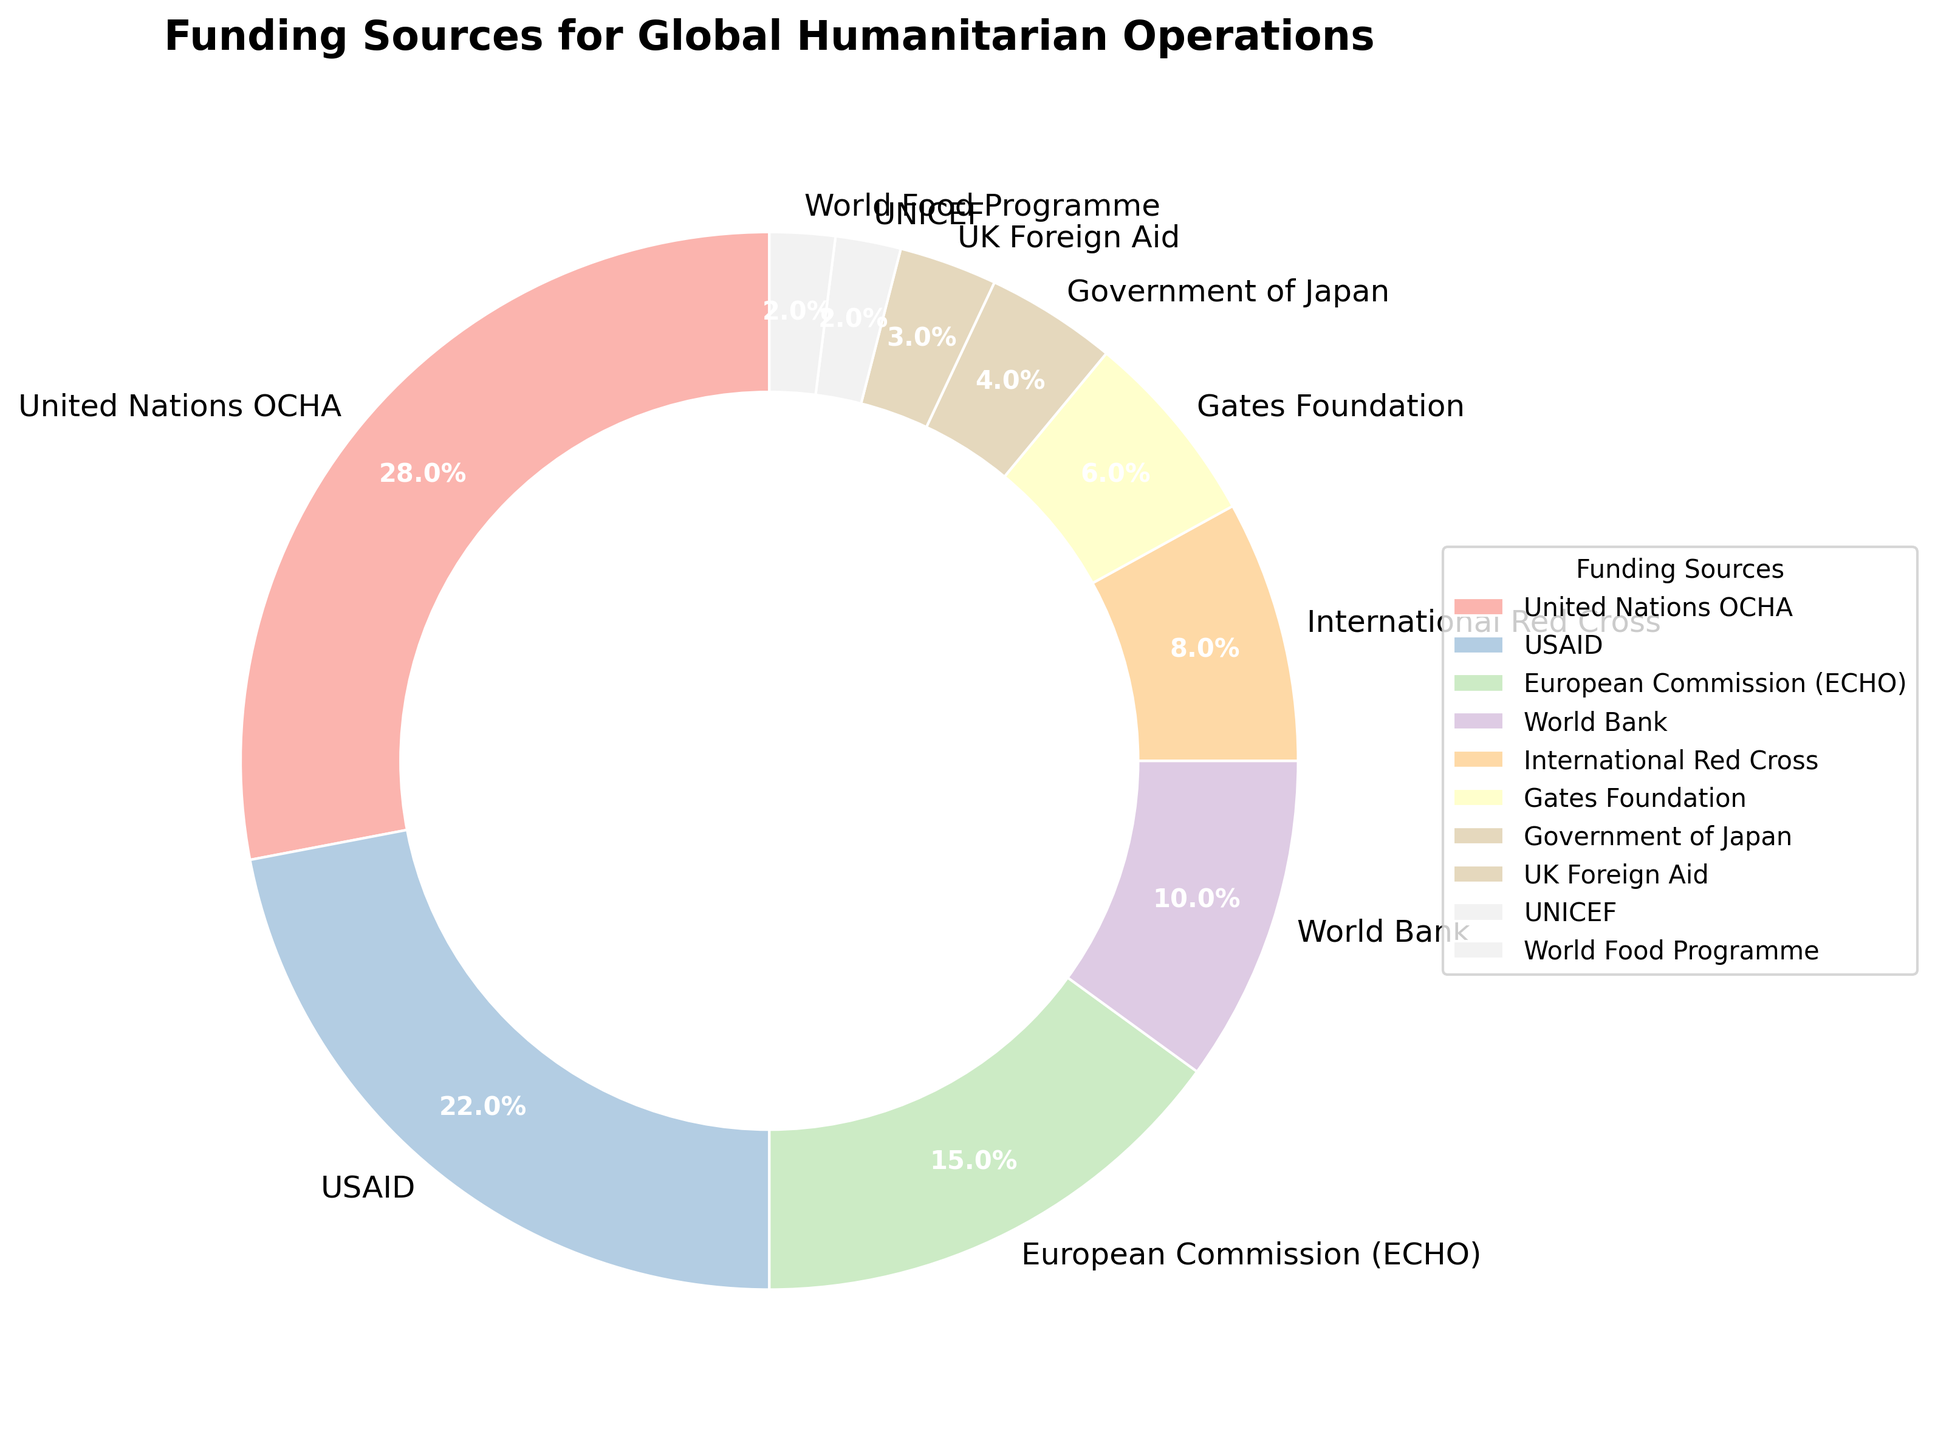Which funding source contributes the largest percentage? From the pie chart, the largest segment represents the United Nations OCHA with 28%, which is the highest among all funding sources.
Answer: United Nations OCHA What is the combined percentage of funding from USAID and the European Commission (ECHO)? The pie chart shows that USAID has 22% and the European Commission (ECHO) has 15%. Summing these percentages gives 22% + 15% = 37%.
Answer: 37% How does the percentage of funding from the World Bank compare to that from the International Red Cross? According to the pie chart, the World Bank contributes 10%, while the International Red Cross contributes 8%. Therefore, the World Bank contributes 2% more than the International Red Cross.
Answer: 2% more Which funding sources contribute less than 5% each? By looking at the segments in the pie chart, the funding sources with contributions less than 5% are the Government of Japan (4%), UK Foreign Aid (3%), UNICEF (2%), and the World Food Programme (2%).
Answer: Government of Japan, UK Foreign Aid, UNICEF, World Food Programme What is the total percentage of funding contributed by non-governmental sources (excluding governments and inter-governmental organizations)? Identifying non-governmental sources: Gates Foundation (6%). Summing their contributions gives 6%.
Answer: 6% What is the difference in percentage between the largest and smallest funding sources? The largest funding source is the United Nations OCHA (28%) and the smallest are UNICEF and the World Food Programme (each 2%). The difference is 28% - 2% = 26%.
Answer: 26% If the funding percentages were evenly divided between the top three sources, what percentage would each source have? The top three sources are United Nations OCHA (28%), USAID (22%), and European Commission (ECHO) (15%). Their total is 28% + 22% + 15% = 65%. Dividing this by three gives 65% / 3 ≈ 21.67%.
Answer: 21.67% How much more funding does the Gates Foundation contribute compared to UNICEF? The Gates Foundation contributes 6% while UNICEF contributes 2%. The difference is 6% - 2% = 4%.
Answer: 4% more Which color is used to represent the World Bank in the pie chart? The World Bank is represented in a segment that corresponds to a shade in the Pastel1 colormap, typically a specific pastel color such as a light blue or light green.
Answer: Light blue/light green What is the sum of the percentages of the funding sources not in the top five? The top five sources are United Nations OCHA (28%), USAID (22%), European Commission (ECHO) (15%), World Bank (10%), and International Red Cross (8%). Summing these yields 28% + 22% + 15% + 10% + 8% = 83%. The total percentage is 100%, so the remainder is 100% - 83% = 17%.
Answer: 17% 